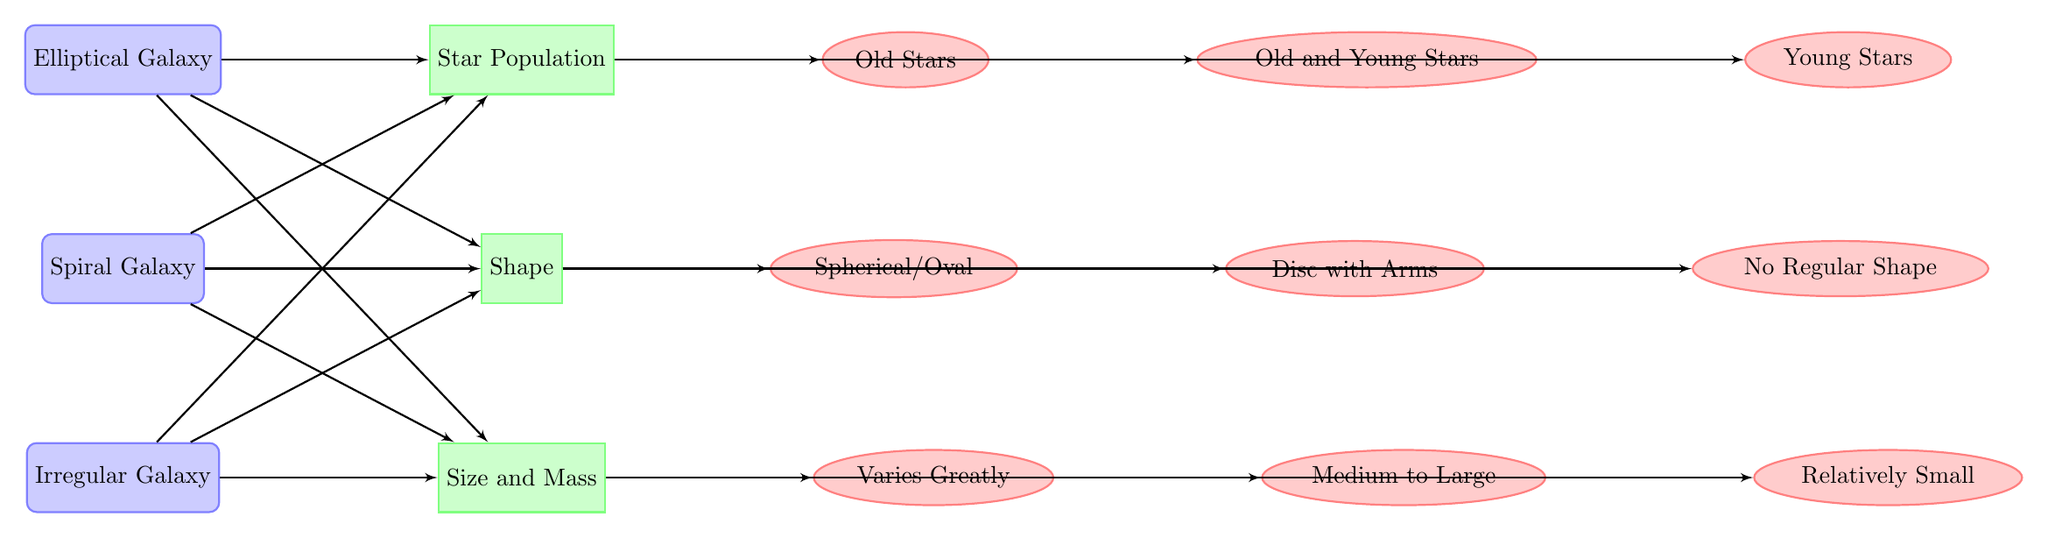What are the three types of galaxies shown in the diagram? The diagram lists three main types of galaxies: Elliptical Galaxy, Spiral Galaxy, and Irregular Galaxy, which can be seen as the main nodes at the top and below in the diagram.
Answer: Elliptical Galaxy, Spiral Galaxy, Irregular Galaxy Which galaxy type is associated with old stars? The detail node for the elliptical galaxy shows the information regarding star population, indicating that it is associated with old stars. This answer can be accessed by following the connection from the Elliptical Galaxy node to the Star Population feature and then to the detail node.
Answer: Old Stars What is the shape description of Spiral Galaxies? The description associated with the Spiral Galaxy node under the shape feature mentions "Disc with Arms," which indicates the shape characteristic of spiral galaxies noted in the diagram. This can be tracked by following the connection from the Spiral Galaxy to the Shape feature and then to the relevant detail node.
Answer: Disc with Arms How many nodes represent the specific characteristics of star populations? The diagram includes three detail nodes that represent the specific characteristics of star populations linked to each galaxy type, thus totaling to three: Old Stars for Elliptical, Old and Young Stars for Spiral, and Young Stars for Irregular galaxies. Therefore, by counting these connections, we find there are three detailed nodes for star populations.
Answer: 3 Which galaxy has the smallest size description? From the detail nodes for size associated with each of the galaxy types, the Irregular Galaxy size is described as "Relatively Small," indicating it has the smallest size when compared to the other types. By following the size connections for each galaxy type, we can determine that Irregular Galaxy has the smallest size characteristic.
Answer: Relatively Small What features connect to the Irregular Galaxy? The Irregular Galaxy is connected by three features to the following detail nodes: Young Stars (star population), No Regular Shape (shape), and Relatively Small (size), which can be tracked by following the connections from Irregular Galaxy to its respective detail nodes.
Answer: Young Stars, No Regular Shape, Relatively Small 